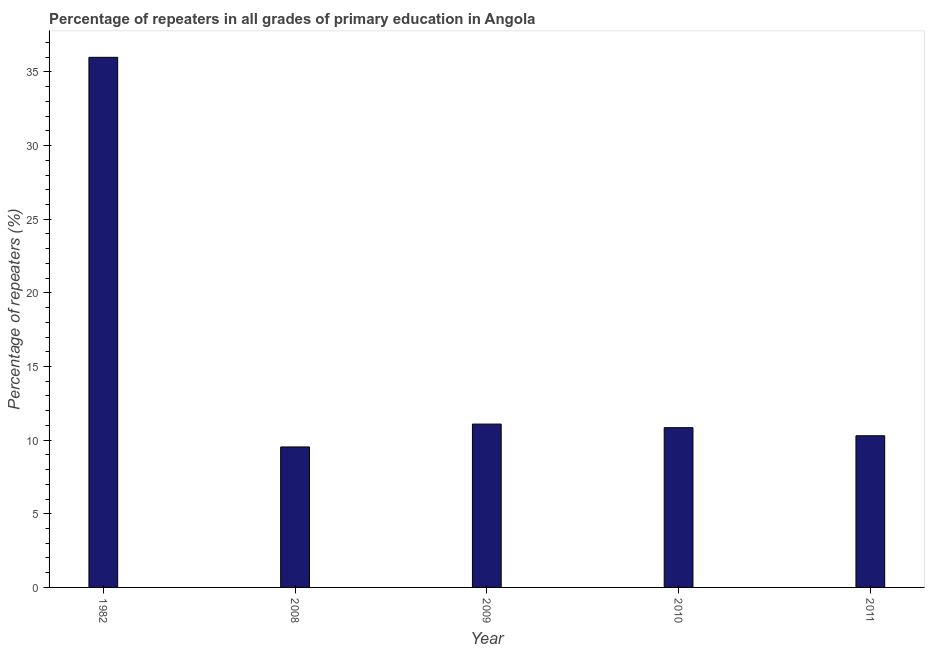Does the graph contain grids?
Your answer should be very brief. No. What is the title of the graph?
Your answer should be compact. Percentage of repeaters in all grades of primary education in Angola. What is the label or title of the X-axis?
Keep it short and to the point. Year. What is the label or title of the Y-axis?
Keep it short and to the point. Percentage of repeaters (%). What is the percentage of repeaters in primary education in 2011?
Your answer should be compact. 10.3. Across all years, what is the maximum percentage of repeaters in primary education?
Give a very brief answer. 35.99. Across all years, what is the minimum percentage of repeaters in primary education?
Make the answer very short. 9.54. In which year was the percentage of repeaters in primary education maximum?
Provide a short and direct response. 1982. In which year was the percentage of repeaters in primary education minimum?
Give a very brief answer. 2008. What is the sum of the percentage of repeaters in primary education?
Give a very brief answer. 77.76. What is the difference between the percentage of repeaters in primary education in 1982 and 2008?
Give a very brief answer. 26.45. What is the average percentage of repeaters in primary education per year?
Make the answer very short. 15.55. What is the median percentage of repeaters in primary education?
Your answer should be compact. 10.85. What is the ratio of the percentage of repeaters in primary education in 1982 to that in 2011?
Offer a very short reply. 3.5. Is the percentage of repeaters in primary education in 1982 less than that in 2009?
Keep it short and to the point. No. Is the difference between the percentage of repeaters in primary education in 2008 and 2009 greater than the difference between any two years?
Your answer should be very brief. No. What is the difference between the highest and the second highest percentage of repeaters in primary education?
Ensure brevity in your answer.  24.9. What is the difference between the highest and the lowest percentage of repeaters in primary education?
Give a very brief answer. 26.45. How many bars are there?
Ensure brevity in your answer.  5. Are all the bars in the graph horizontal?
Offer a terse response. No. What is the difference between two consecutive major ticks on the Y-axis?
Keep it short and to the point. 5. What is the Percentage of repeaters (%) in 1982?
Offer a terse response. 35.99. What is the Percentage of repeaters (%) of 2008?
Ensure brevity in your answer.  9.54. What is the Percentage of repeaters (%) of 2009?
Make the answer very short. 11.09. What is the Percentage of repeaters (%) in 2010?
Provide a succinct answer. 10.85. What is the Percentage of repeaters (%) in 2011?
Give a very brief answer. 10.3. What is the difference between the Percentage of repeaters (%) in 1982 and 2008?
Provide a succinct answer. 26.45. What is the difference between the Percentage of repeaters (%) in 1982 and 2009?
Make the answer very short. 24.9. What is the difference between the Percentage of repeaters (%) in 1982 and 2010?
Keep it short and to the point. 25.14. What is the difference between the Percentage of repeaters (%) in 1982 and 2011?
Keep it short and to the point. 25.69. What is the difference between the Percentage of repeaters (%) in 2008 and 2009?
Give a very brief answer. -1.55. What is the difference between the Percentage of repeaters (%) in 2008 and 2010?
Make the answer very short. -1.31. What is the difference between the Percentage of repeaters (%) in 2008 and 2011?
Make the answer very short. -0.76. What is the difference between the Percentage of repeaters (%) in 2009 and 2010?
Keep it short and to the point. 0.24. What is the difference between the Percentage of repeaters (%) in 2009 and 2011?
Offer a terse response. 0.79. What is the difference between the Percentage of repeaters (%) in 2010 and 2011?
Your response must be concise. 0.55. What is the ratio of the Percentage of repeaters (%) in 1982 to that in 2008?
Ensure brevity in your answer.  3.77. What is the ratio of the Percentage of repeaters (%) in 1982 to that in 2009?
Keep it short and to the point. 3.25. What is the ratio of the Percentage of repeaters (%) in 1982 to that in 2010?
Offer a very short reply. 3.32. What is the ratio of the Percentage of repeaters (%) in 1982 to that in 2011?
Keep it short and to the point. 3.5. What is the ratio of the Percentage of repeaters (%) in 2008 to that in 2009?
Your answer should be very brief. 0.86. What is the ratio of the Percentage of repeaters (%) in 2008 to that in 2010?
Make the answer very short. 0.88. What is the ratio of the Percentage of repeaters (%) in 2008 to that in 2011?
Your answer should be compact. 0.93. What is the ratio of the Percentage of repeaters (%) in 2009 to that in 2011?
Make the answer very short. 1.08. What is the ratio of the Percentage of repeaters (%) in 2010 to that in 2011?
Ensure brevity in your answer.  1.05. 